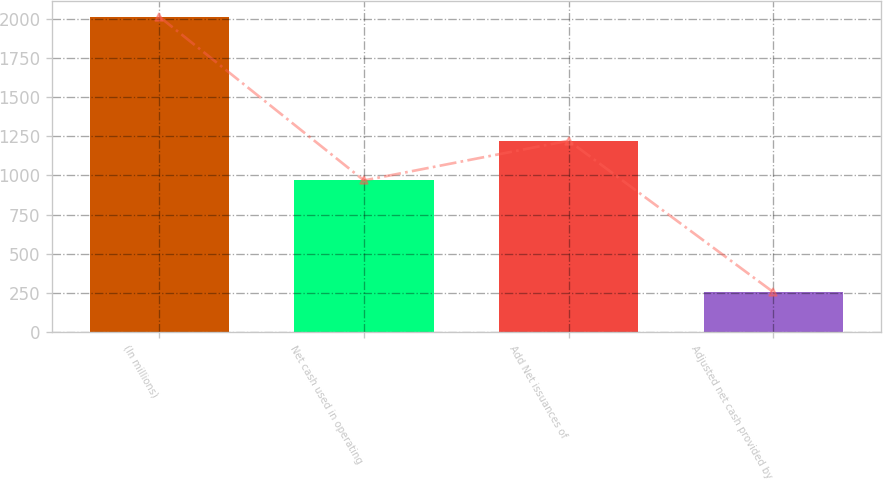<chart> <loc_0><loc_0><loc_500><loc_500><bar_chart><fcel>(In millions)<fcel>Net cash used in operating<fcel>Add Net issuances of<fcel>Adjusted net cash provided by<nl><fcel>2015<fcel>968.1<fcel>1222.2<fcel>254.1<nl></chart> 